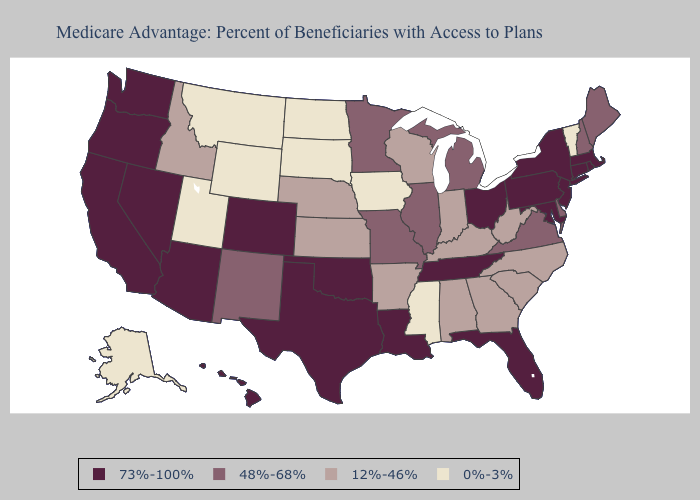What is the value of Georgia?
Write a very short answer. 12%-46%. Does Montana have the highest value in the West?
Be succinct. No. Name the states that have a value in the range 73%-100%?
Short answer required. Arizona, California, Colorado, Connecticut, Florida, Hawaii, Louisiana, Massachusetts, Maryland, New Jersey, Nevada, New York, Ohio, Oklahoma, Oregon, Pennsylvania, Rhode Island, Tennessee, Texas, Washington. How many symbols are there in the legend?
Keep it brief. 4. Name the states that have a value in the range 48%-68%?
Give a very brief answer. Delaware, Illinois, Maine, Michigan, Minnesota, Missouri, New Hampshire, New Mexico, Virginia. What is the value of Oklahoma?
Concise answer only. 73%-100%. What is the highest value in the USA?
Quick response, please. 73%-100%. What is the highest value in the USA?
Short answer required. 73%-100%. Name the states that have a value in the range 12%-46%?
Quick response, please. Alabama, Arkansas, Georgia, Idaho, Indiana, Kansas, Kentucky, North Carolina, Nebraska, South Carolina, Wisconsin, West Virginia. What is the lowest value in the South?
Answer briefly. 0%-3%. Among the states that border Arkansas , which have the lowest value?
Keep it brief. Mississippi. Which states have the lowest value in the Northeast?
Write a very short answer. Vermont. Which states hav the highest value in the Northeast?
Quick response, please. Connecticut, Massachusetts, New Jersey, New York, Pennsylvania, Rhode Island. Name the states that have a value in the range 73%-100%?
Short answer required. Arizona, California, Colorado, Connecticut, Florida, Hawaii, Louisiana, Massachusetts, Maryland, New Jersey, Nevada, New York, Ohio, Oklahoma, Oregon, Pennsylvania, Rhode Island, Tennessee, Texas, Washington. Among the states that border Oregon , does Washington have the highest value?
Keep it brief. Yes. 